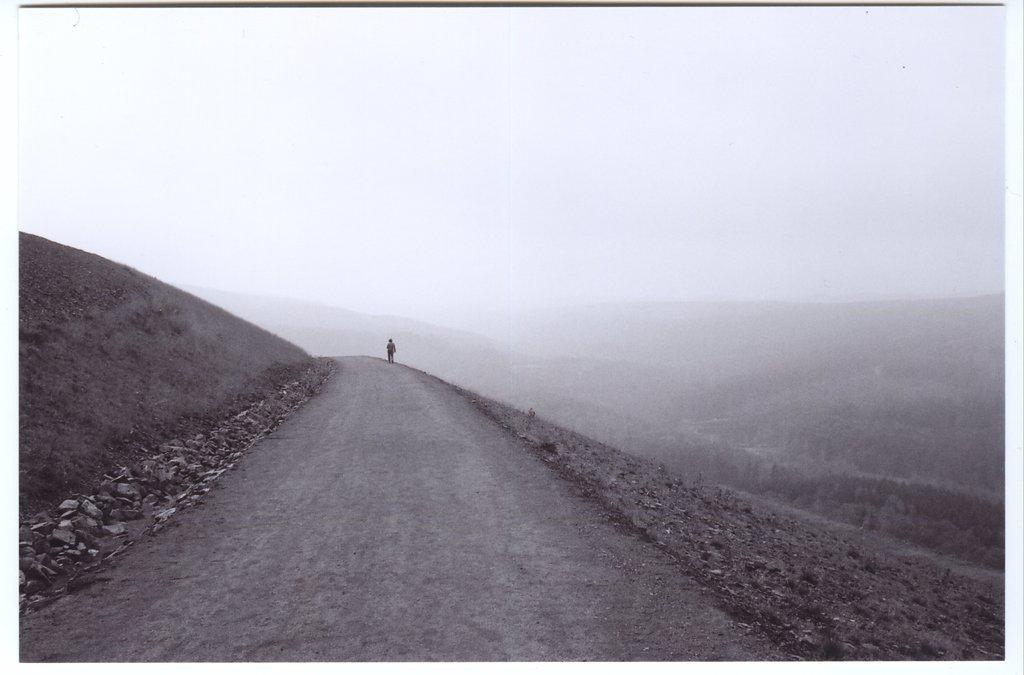Can you describe this image briefly? In this image there is a person walking on the road. Image also consists of many trees. Sky is also visible. Stones are also present in this image. 